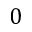<formula> <loc_0><loc_0><loc_500><loc_500>0</formula> 